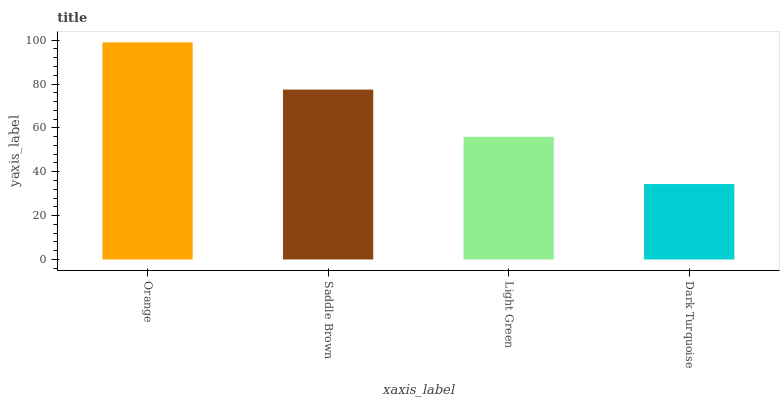Is Saddle Brown the minimum?
Answer yes or no. No. Is Saddle Brown the maximum?
Answer yes or no. No. Is Orange greater than Saddle Brown?
Answer yes or no. Yes. Is Saddle Brown less than Orange?
Answer yes or no. Yes. Is Saddle Brown greater than Orange?
Answer yes or no. No. Is Orange less than Saddle Brown?
Answer yes or no. No. Is Saddle Brown the high median?
Answer yes or no. Yes. Is Light Green the low median?
Answer yes or no. Yes. Is Light Green the high median?
Answer yes or no. No. Is Dark Turquoise the low median?
Answer yes or no. No. 